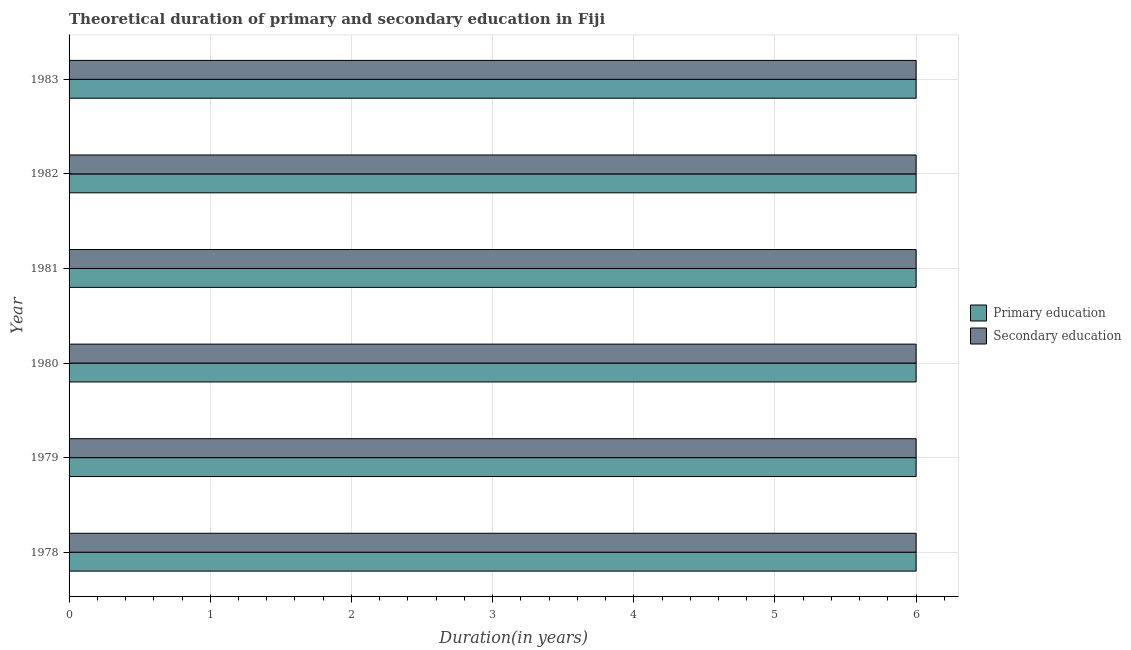How many groups of bars are there?
Offer a terse response. 6. Are the number of bars per tick equal to the number of legend labels?
Make the answer very short. Yes. How many bars are there on the 3rd tick from the bottom?
Give a very brief answer. 2. What is the label of the 2nd group of bars from the top?
Offer a terse response. 1982. What is the duration of secondary education in 1983?
Provide a short and direct response. 6. In which year was the duration of secondary education maximum?
Your response must be concise. 1978. In which year was the duration of secondary education minimum?
Your response must be concise. 1978. What is the total duration of secondary education in the graph?
Give a very brief answer. 36. What is the average duration of primary education per year?
Provide a short and direct response. 6. In how many years, is the duration of secondary education greater than 2.6 years?
Provide a short and direct response. 6. Is the duration of secondary education in 1979 less than that in 1982?
Offer a very short reply. No. What is the difference between the highest and the lowest duration of primary education?
Keep it short and to the point. 0. In how many years, is the duration of secondary education greater than the average duration of secondary education taken over all years?
Your response must be concise. 0. What does the 1st bar from the top in 1982 represents?
Provide a succinct answer. Secondary education. What does the 1st bar from the bottom in 1982 represents?
Offer a terse response. Primary education. Are the values on the major ticks of X-axis written in scientific E-notation?
Make the answer very short. No. Does the graph contain any zero values?
Your answer should be very brief. No. What is the title of the graph?
Your response must be concise. Theoretical duration of primary and secondary education in Fiji. Does "Gasoline" appear as one of the legend labels in the graph?
Your answer should be compact. No. What is the label or title of the X-axis?
Offer a very short reply. Duration(in years). What is the label or title of the Y-axis?
Provide a short and direct response. Year. What is the Duration(in years) of Secondary education in 1978?
Give a very brief answer. 6. What is the Duration(in years) in Secondary education in 1979?
Your response must be concise. 6. What is the Duration(in years) of Secondary education in 1980?
Your answer should be compact. 6. What is the Duration(in years) in Secondary education in 1981?
Ensure brevity in your answer.  6. What is the Duration(in years) of Primary education in 1982?
Your response must be concise. 6. What is the Duration(in years) in Primary education in 1983?
Your response must be concise. 6. Across all years, what is the minimum Duration(in years) of Primary education?
Offer a very short reply. 6. Across all years, what is the minimum Duration(in years) in Secondary education?
Your response must be concise. 6. What is the total Duration(in years) of Primary education in the graph?
Offer a terse response. 36. What is the difference between the Duration(in years) of Secondary education in 1978 and that in 1979?
Offer a very short reply. 0. What is the difference between the Duration(in years) in Primary education in 1978 and that in 1981?
Offer a very short reply. 0. What is the difference between the Duration(in years) of Secondary education in 1978 and that in 1981?
Make the answer very short. 0. What is the difference between the Duration(in years) in Secondary education in 1978 and that in 1982?
Your answer should be very brief. 0. What is the difference between the Duration(in years) in Secondary education in 1979 and that in 1980?
Offer a very short reply. 0. What is the difference between the Duration(in years) of Primary education in 1979 and that in 1983?
Offer a terse response. 0. What is the difference between the Duration(in years) in Secondary education in 1979 and that in 1983?
Offer a very short reply. 0. What is the difference between the Duration(in years) in Primary education in 1980 and that in 1981?
Your response must be concise. 0. What is the difference between the Duration(in years) of Secondary education in 1980 and that in 1981?
Give a very brief answer. 0. What is the difference between the Duration(in years) in Primary education in 1980 and that in 1982?
Your answer should be compact. 0. What is the difference between the Duration(in years) in Secondary education in 1980 and that in 1982?
Keep it short and to the point. 0. What is the difference between the Duration(in years) in Primary education in 1981 and that in 1982?
Provide a succinct answer. 0. What is the difference between the Duration(in years) of Secondary education in 1981 and that in 1983?
Ensure brevity in your answer.  0. What is the difference between the Duration(in years) of Primary education in 1982 and that in 1983?
Your answer should be very brief. 0. What is the difference between the Duration(in years) of Secondary education in 1982 and that in 1983?
Offer a very short reply. 0. What is the difference between the Duration(in years) in Primary education in 1978 and the Duration(in years) in Secondary education in 1979?
Your response must be concise. 0. What is the difference between the Duration(in years) in Primary education in 1979 and the Duration(in years) in Secondary education in 1982?
Ensure brevity in your answer.  0. What is the difference between the Duration(in years) in Primary education in 1979 and the Duration(in years) in Secondary education in 1983?
Offer a terse response. 0. What is the difference between the Duration(in years) of Primary education in 1980 and the Duration(in years) of Secondary education in 1982?
Provide a succinct answer. 0. What is the difference between the Duration(in years) of Primary education in 1980 and the Duration(in years) of Secondary education in 1983?
Provide a short and direct response. 0. What is the difference between the Duration(in years) in Primary education in 1981 and the Duration(in years) in Secondary education in 1982?
Offer a very short reply. 0. What is the average Duration(in years) of Primary education per year?
Your response must be concise. 6. What is the average Duration(in years) in Secondary education per year?
Provide a short and direct response. 6. In the year 1978, what is the difference between the Duration(in years) in Primary education and Duration(in years) in Secondary education?
Keep it short and to the point. 0. In the year 1979, what is the difference between the Duration(in years) of Primary education and Duration(in years) of Secondary education?
Give a very brief answer. 0. In the year 1981, what is the difference between the Duration(in years) in Primary education and Duration(in years) in Secondary education?
Ensure brevity in your answer.  0. What is the ratio of the Duration(in years) in Secondary education in 1978 to that in 1979?
Ensure brevity in your answer.  1. What is the ratio of the Duration(in years) of Secondary education in 1978 to that in 1980?
Make the answer very short. 1. What is the ratio of the Duration(in years) in Primary education in 1978 to that in 1981?
Make the answer very short. 1. What is the ratio of the Duration(in years) in Secondary education in 1978 to that in 1981?
Keep it short and to the point. 1. What is the ratio of the Duration(in years) in Primary education in 1978 to that in 1982?
Your answer should be compact. 1. What is the ratio of the Duration(in years) in Primary education in 1979 to that in 1980?
Offer a very short reply. 1. What is the ratio of the Duration(in years) in Primary education in 1979 to that in 1981?
Your response must be concise. 1. What is the ratio of the Duration(in years) in Primary education in 1979 to that in 1983?
Your answer should be compact. 1. What is the ratio of the Duration(in years) in Primary education in 1980 to that in 1981?
Keep it short and to the point. 1. What is the ratio of the Duration(in years) in Secondary education in 1980 to that in 1982?
Ensure brevity in your answer.  1. What is the ratio of the Duration(in years) of Primary education in 1980 to that in 1983?
Your response must be concise. 1. What is the ratio of the Duration(in years) of Secondary education in 1980 to that in 1983?
Give a very brief answer. 1. What is the ratio of the Duration(in years) of Primary education in 1981 to that in 1982?
Ensure brevity in your answer.  1. What is the ratio of the Duration(in years) in Primary education in 1982 to that in 1983?
Your answer should be very brief. 1. What is the ratio of the Duration(in years) of Secondary education in 1982 to that in 1983?
Your answer should be compact. 1. What is the difference between the highest and the second highest Duration(in years) in Secondary education?
Provide a short and direct response. 0. What is the difference between the highest and the lowest Duration(in years) in Primary education?
Ensure brevity in your answer.  0. What is the difference between the highest and the lowest Duration(in years) in Secondary education?
Offer a very short reply. 0. 